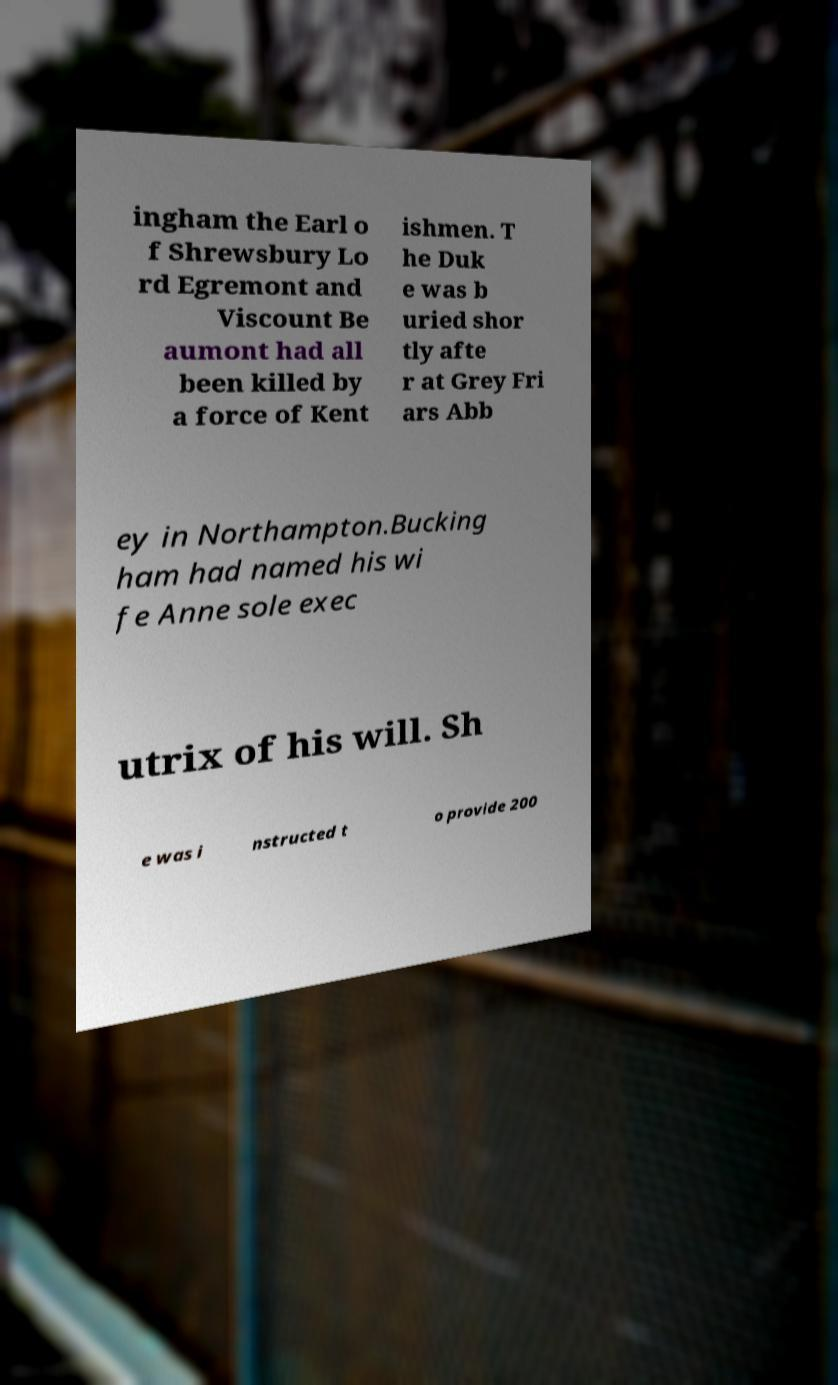Could you assist in decoding the text presented in this image and type it out clearly? ingham the Earl o f Shrewsbury Lo rd Egremont and Viscount Be aumont had all been killed by a force of Kent ishmen. T he Duk e was b uried shor tly afte r at Grey Fri ars Abb ey in Northampton.Bucking ham had named his wi fe Anne sole exec utrix of his will. Sh e was i nstructed t o provide 200 